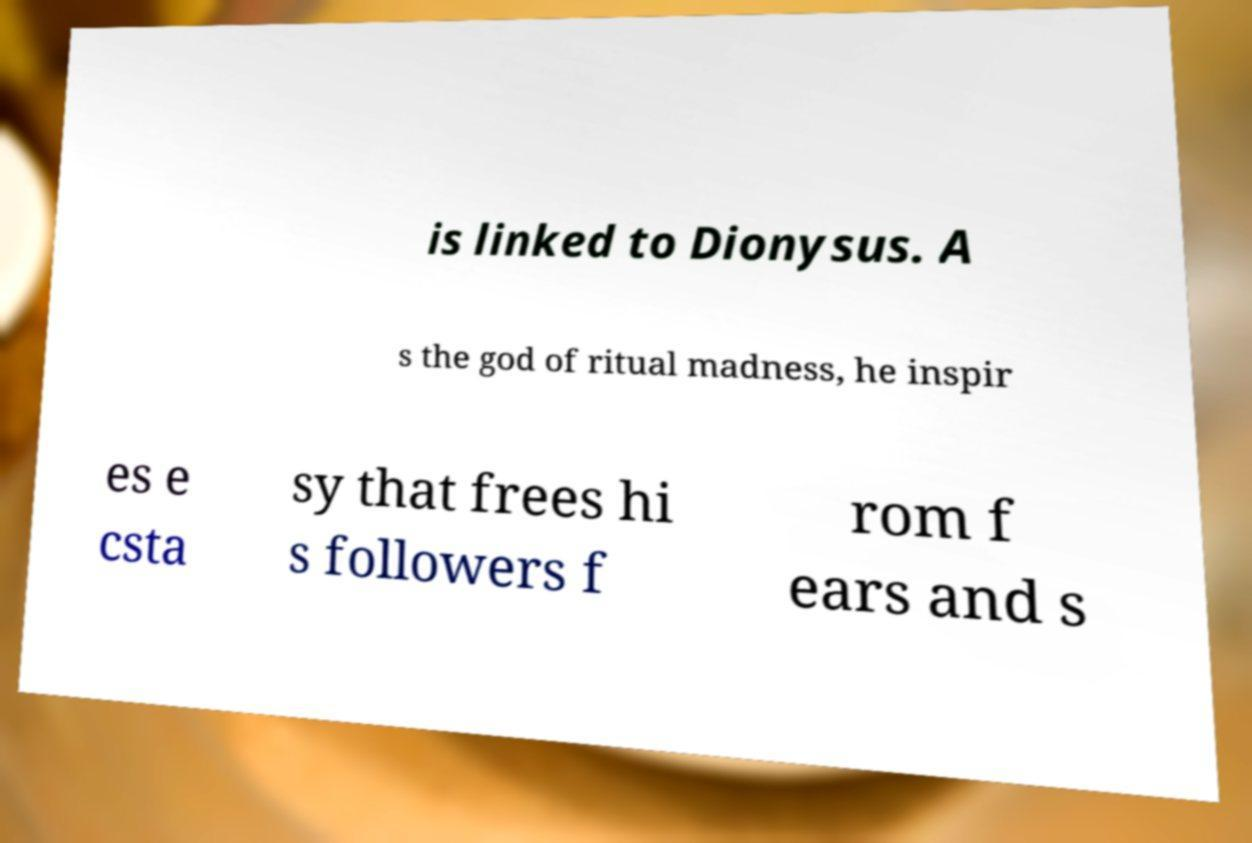Could you assist in decoding the text presented in this image and type it out clearly? is linked to Dionysus. A s the god of ritual madness, he inspir es e csta sy that frees hi s followers f rom f ears and s 